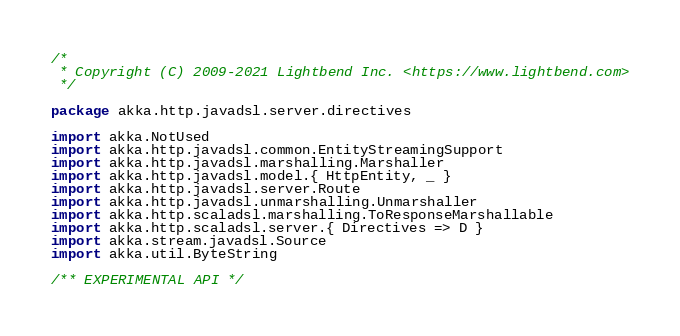<code> <loc_0><loc_0><loc_500><loc_500><_Scala_>/*
 * Copyright (C) 2009-2021 Lightbend Inc. <https://www.lightbend.com>
 */

package akka.http.javadsl.server.directives

import akka.NotUsed
import akka.http.javadsl.common.EntityStreamingSupport
import akka.http.javadsl.marshalling.Marshaller
import akka.http.javadsl.model.{ HttpEntity, _ }
import akka.http.javadsl.server.Route
import akka.http.javadsl.unmarshalling.Unmarshaller
import akka.http.scaladsl.marshalling.ToResponseMarshallable
import akka.http.scaladsl.server.{ Directives => D }
import akka.stream.javadsl.Source
import akka.util.ByteString

/** EXPERIMENTAL API */</code> 